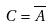<formula> <loc_0><loc_0><loc_500><loc_500>C = \overline { A }</formula> 